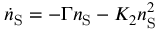<formula> <loc_0><loc_0><loc_500><loc_500>\dot { n } _ { S } = - \Gamma n _ { S } - K _ { 2 } n _ { S } ^ { 2 }</formula> 